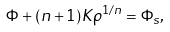Convert formula to latex. <formula><loc_0><loc_0><loc_500><loc_500>\Phi + ( n + 1 ) K \rho ^ { 1 / n } = \Phi _ { s } ,</formula> 